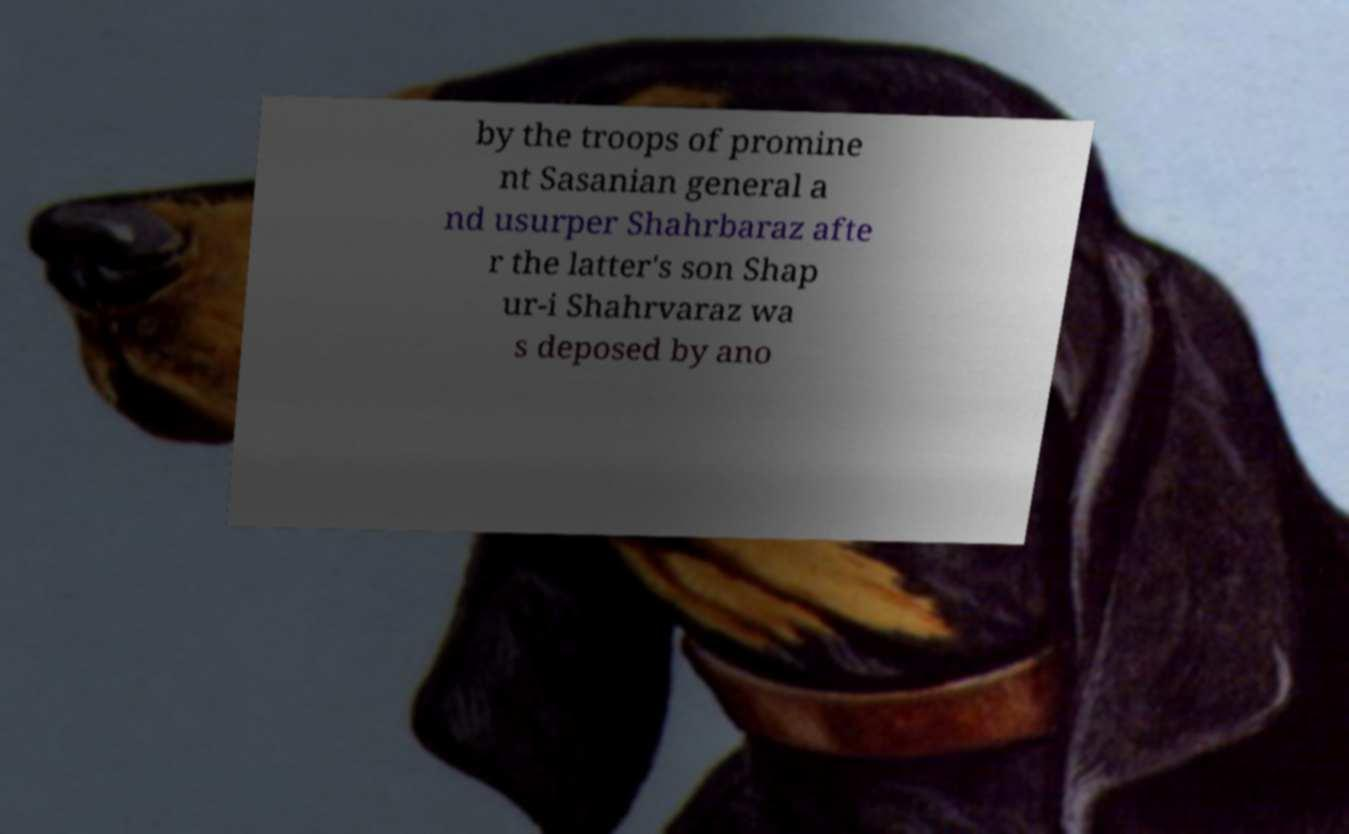Can you read and provide the text displayed in the image?This photo seems to have some interesting text. Can you extract and type it out for me? by the troops of promine nt Sasanian general a nd usurper Shahrbaraz afte r the latter's son Shap ur-i Shahrvaraz wa s deposed by ano 